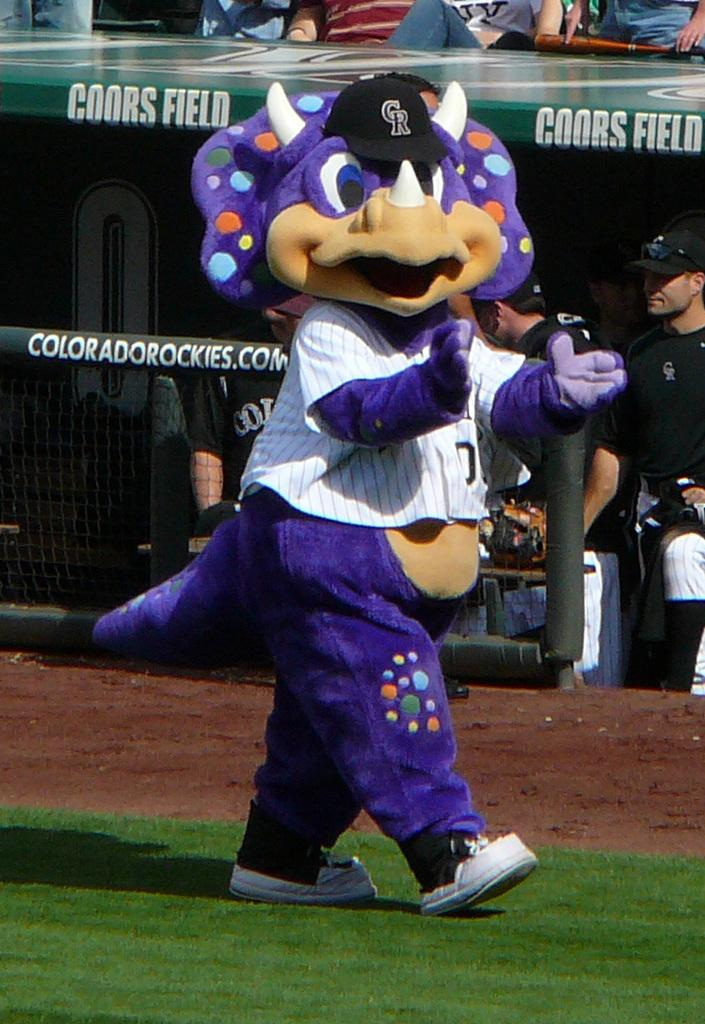<image>
Relay a brief, clear account of the picture shown. A baseball mascot in a stegasaurus costume walks past the Colorado Rockies dugout. 